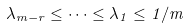<formula> <loc_0><loc_0><loc_500><loc_500>\lambda _ { m - r } \leq \cdots \leq \lambda _ { 1 } \leq 1 / m</formula> 